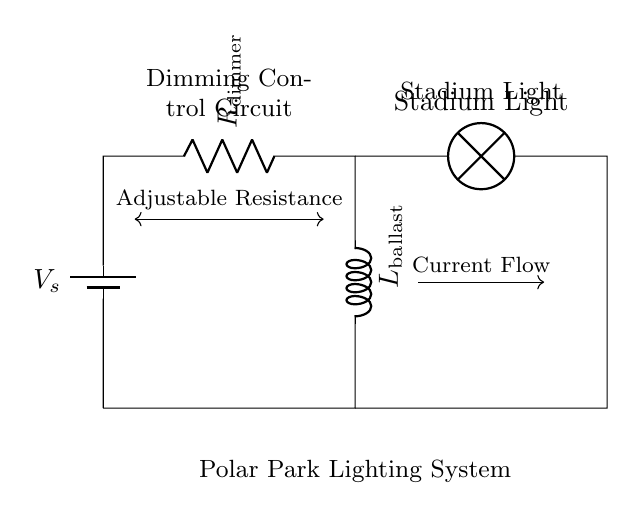What component limits current in this circuit? The component that limits current in the circuit is the resistor, which is labeled as R_dimmer. It is connected in series with the inductor to control the amount of current flowing through the circuit.
Answer: R_dimmer What type of circuit is shown? The circuit shown is a resistor-inductor circuit, as it includes a resistor and an inductor in series, which are used to form a dimming control for the stadium lights.
Answer: Resistor-Inductor What is the main purpose of L_ballast in this circuit? The main purpose of the inductor, L_ballast, is to provide inductance in the circuit, which helps to regulate the current and prevent sudden changes, thus helping in the dimming control of the stadium lights.
Answer: Regulate current How does adjusting R_dimmer affect the stadium lights? Adjusting R_dimmer changes the resistance in the circuit, which influences the amount of current flowing through the inductor and the stadium lights. Increasing the resistance generally leads to dimmer lights, while decreasing it increases brightness.
Answer: Changes brightness What does the arrow indicating current flow represent? The arrow indicating current flow represents the direction of the current in the circuit from the source to the load (stadium light), showing how the energy is transmitted through the components.
Answer: Current direction What type of load is connected at the end of this circuit? The load connected at the end of this circuit is a lamp, specifically labeled as Stadium Light, which is the component that provides illumination for the stadium.
Answer: Stadium Light 